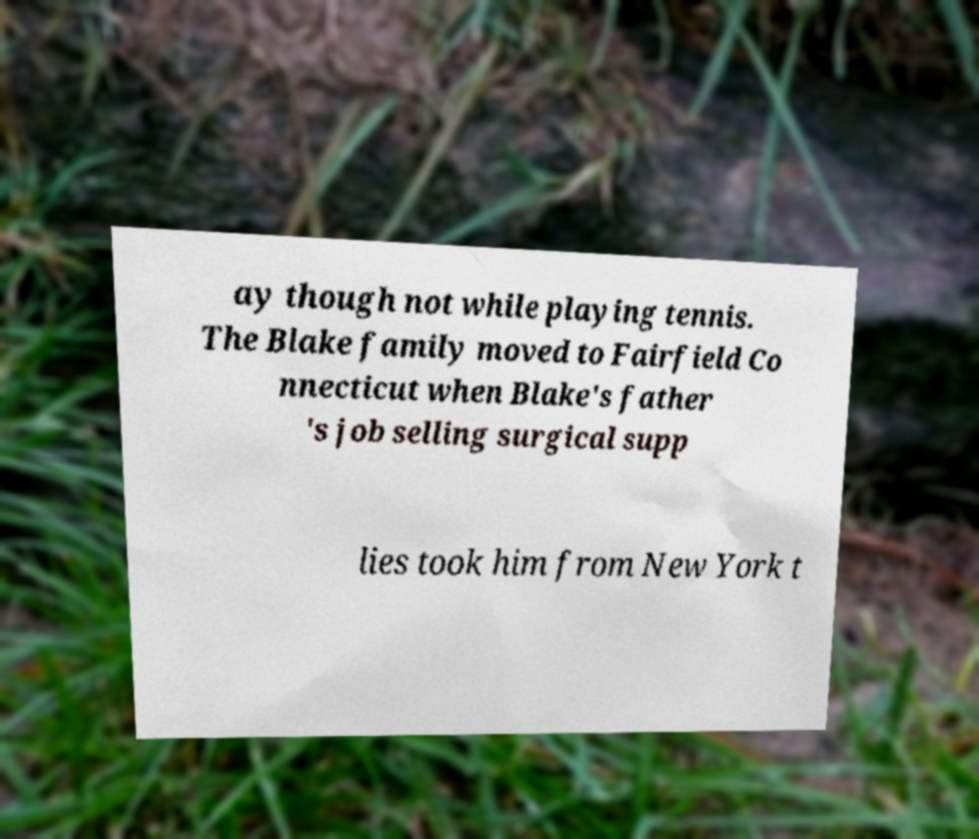What messages or text are displayed in this image? I need them in a readable, typed format. ay though not while playing tennis. The Blake family moved to Fairfield Co nnecticut when Blake's father 's job selling surgical supp lies took him from New York t 